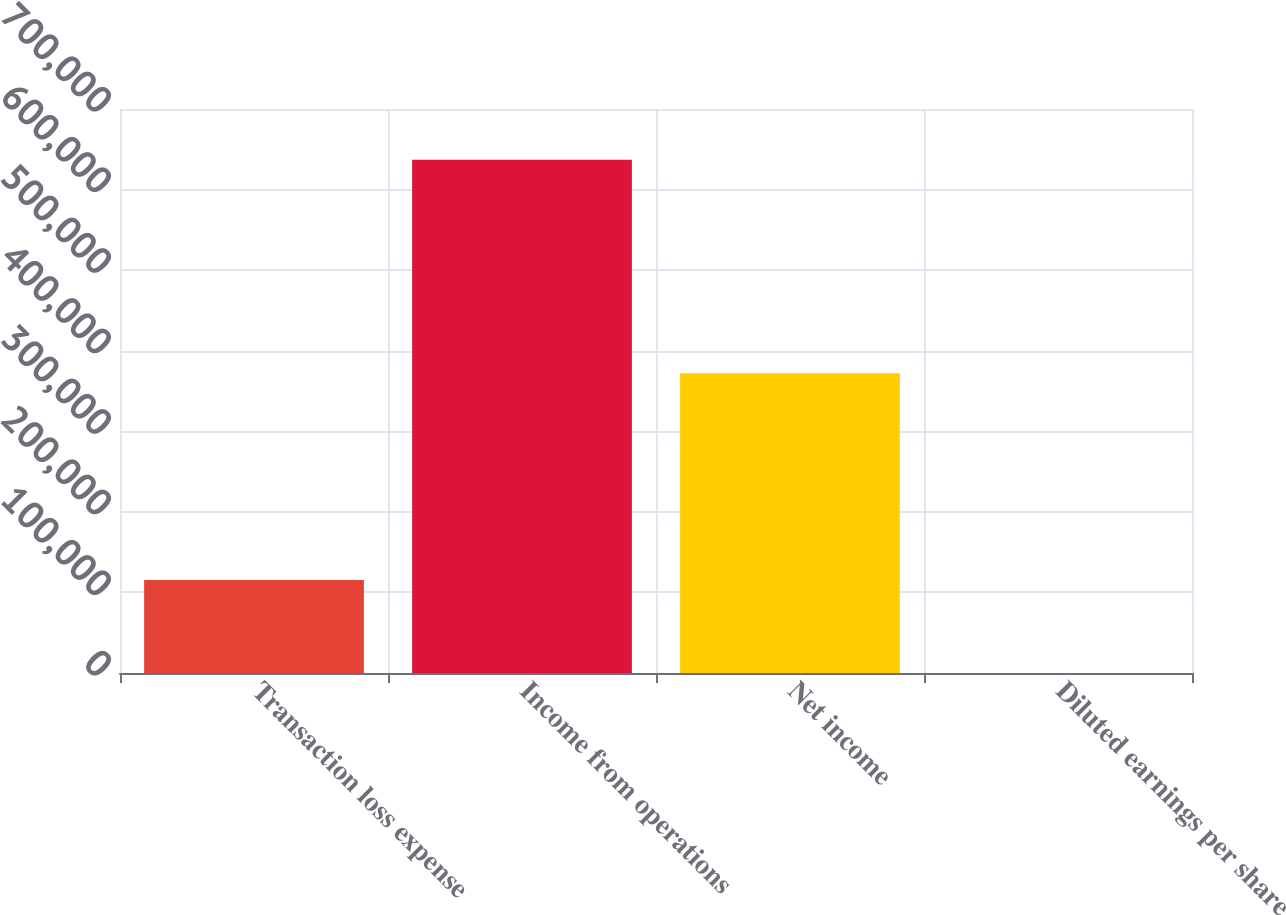<chart> <loc_0><loc_0><loc_500><loc_500><bar_chart><fcel>Transaction loss expense<fcel>Income from operations<fcel>Net income<fcel>Diluted earnings per share<nl><fcel>115520<fcel>636915<fcel>371986<fcel>0.27<nl></chart> 